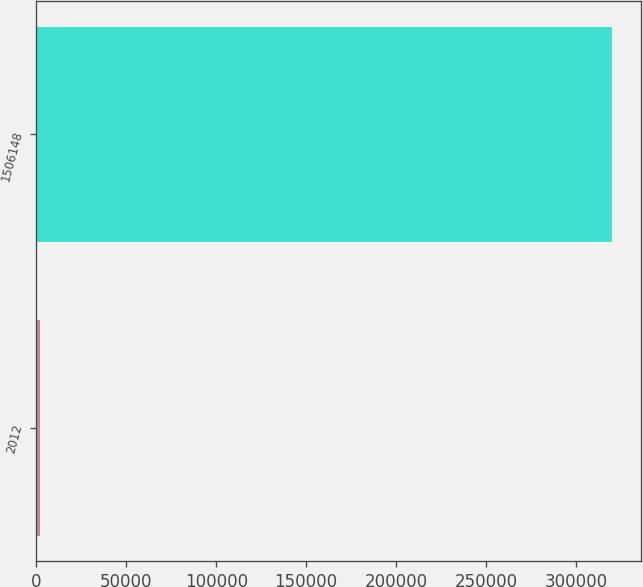<chart> <loc_0><loc_0><loc_500><loc_500><bar_chart><fcel>2012<fcel>1506148<nl><fcel>2011<fcel>320143<nl></chart> 